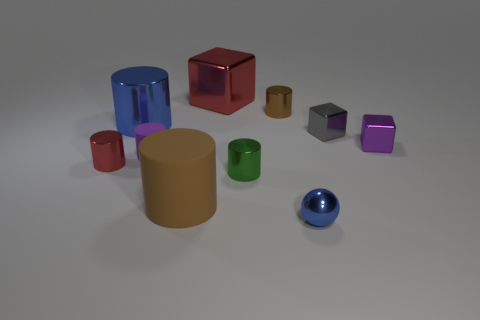There is a tiny shiny thing that is the same color as the large rubber cylinder; what shape is it?
Make the answer very short. Cylinder. What number of things are large blocks or big gray blocks?
Give a very brief answer. 1. Do the small red thing and the large red metal thing have the same shape?
Your answer should be very brief. No. What is the material of the red cube?
Give a very brief answer. Metal. What number of things are on the left side of the big brown matte thing and behind the small purple metallic thing?
Keep it short and to the point. 1. Do the brown metallic cylinder and the red metal cylinder have the same size?
Keep it short and to the point. Yes. Do the rubber cylinder in front of the purple cylinder and the small metal sphere have the same size?
Provide a short and direct response. No. What is the color of the small shiny cylinder that is to the left of the blue cylinder?
Provide a succinct answer. Red. How many large cyan cylinders are there?
Make the answer very short. 0. What shape is the small purple thing that is the same material as the small gray object?
Offer a very short reply. Cube. 